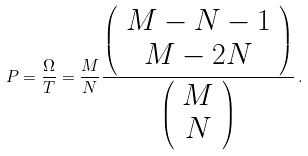<formula> <loc_0><loc_0><loc_500><loc_500>P = \frac { \Omega } { T } = \frac { M } { N } \frac { \left ( \begin{array} { c } M - N - 1 \\ M - 2 N \end{array} \right ) } { \left ( \begin{array} { c } M \\ N \end{array} \right ) } \, .</formula> 